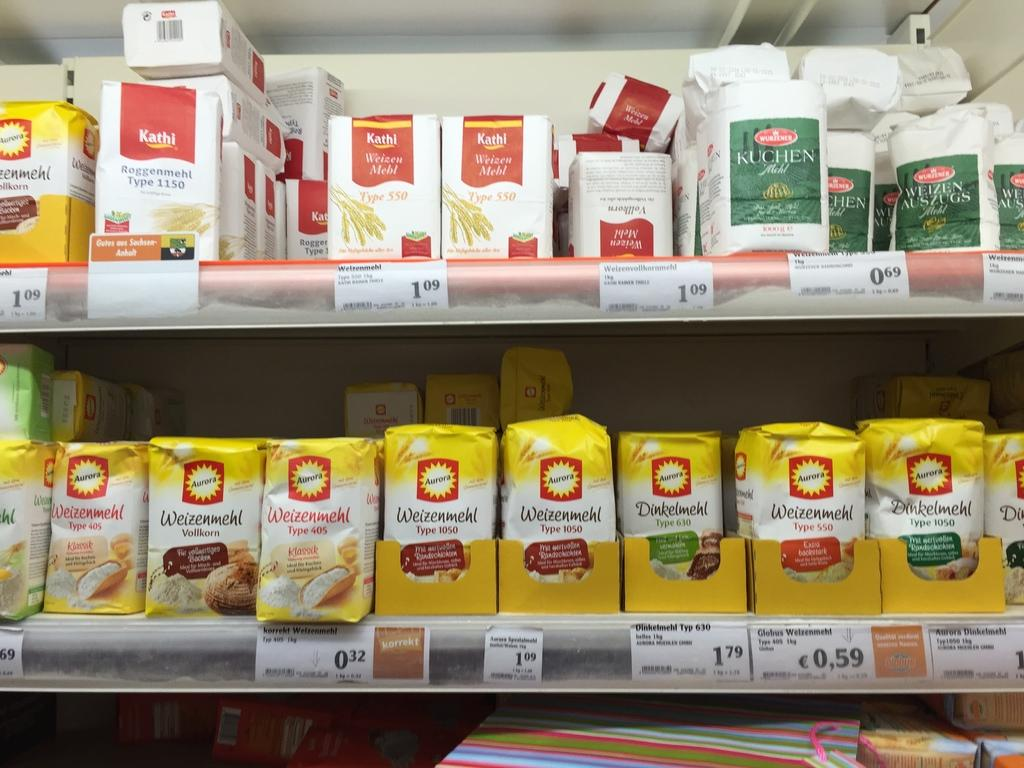<image>
Offer a succinct explanation of the picture presented. Many bags of Weizenmehl on a shelf at a store. 